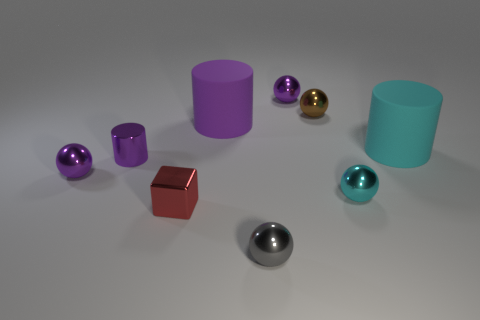Are there any other things that have the same shape as the tiny red shiny object?
Keep it short and to the point. No. The other rubber cylinder that is the same size as the cyan matte cylinder is what color?
Your response must be concise. Purple. There is a small gray metal thing that is right of the large object that is left of the small gray metal object; are there any balls that are behind it?
Offer a very short reply. Yes. There is a purple cylinder right of the red shiny object; what material is it?
Provide a succinct answer. Rubber. There is a large purple object; is it the same shape as the cyan thing behind the metallic cylinder?
Offer a terse response. Yes. Are there the same number of cubes behind the big purple cylinder and small cyan balls on the left side of the gray shiny object?
Your answer should be very brief. Yes. How many other things are there of the same material as the brown object?
Keep it short and to the point. 6. What number of metallic objects are big cylinders or tiny brown things?
Your response must be concise. 1. There is a metal object that is behind the tiny brown ball; is its shape the same as the brown object?
Your answer should be very brief. Yes. Are there more metal cubes that are in front of the red cube than gray shiny spheres?
Give a very brief answer. No. 